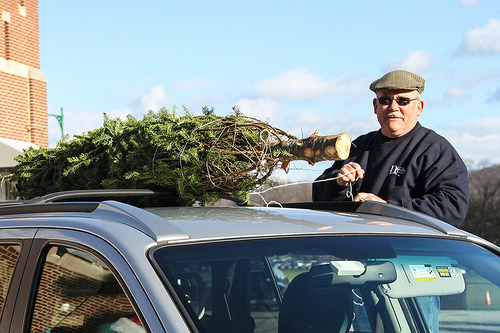<image>
Is the tree behind the car? No. The tree is not behind the car. From this viewpoint, the tree appears to be positioned elsewhere in the scene. Is the tree behind the man? No. The tree is not behind the man. From this viewpoint, the tree appears to be positioned elsewhere in the scene. 